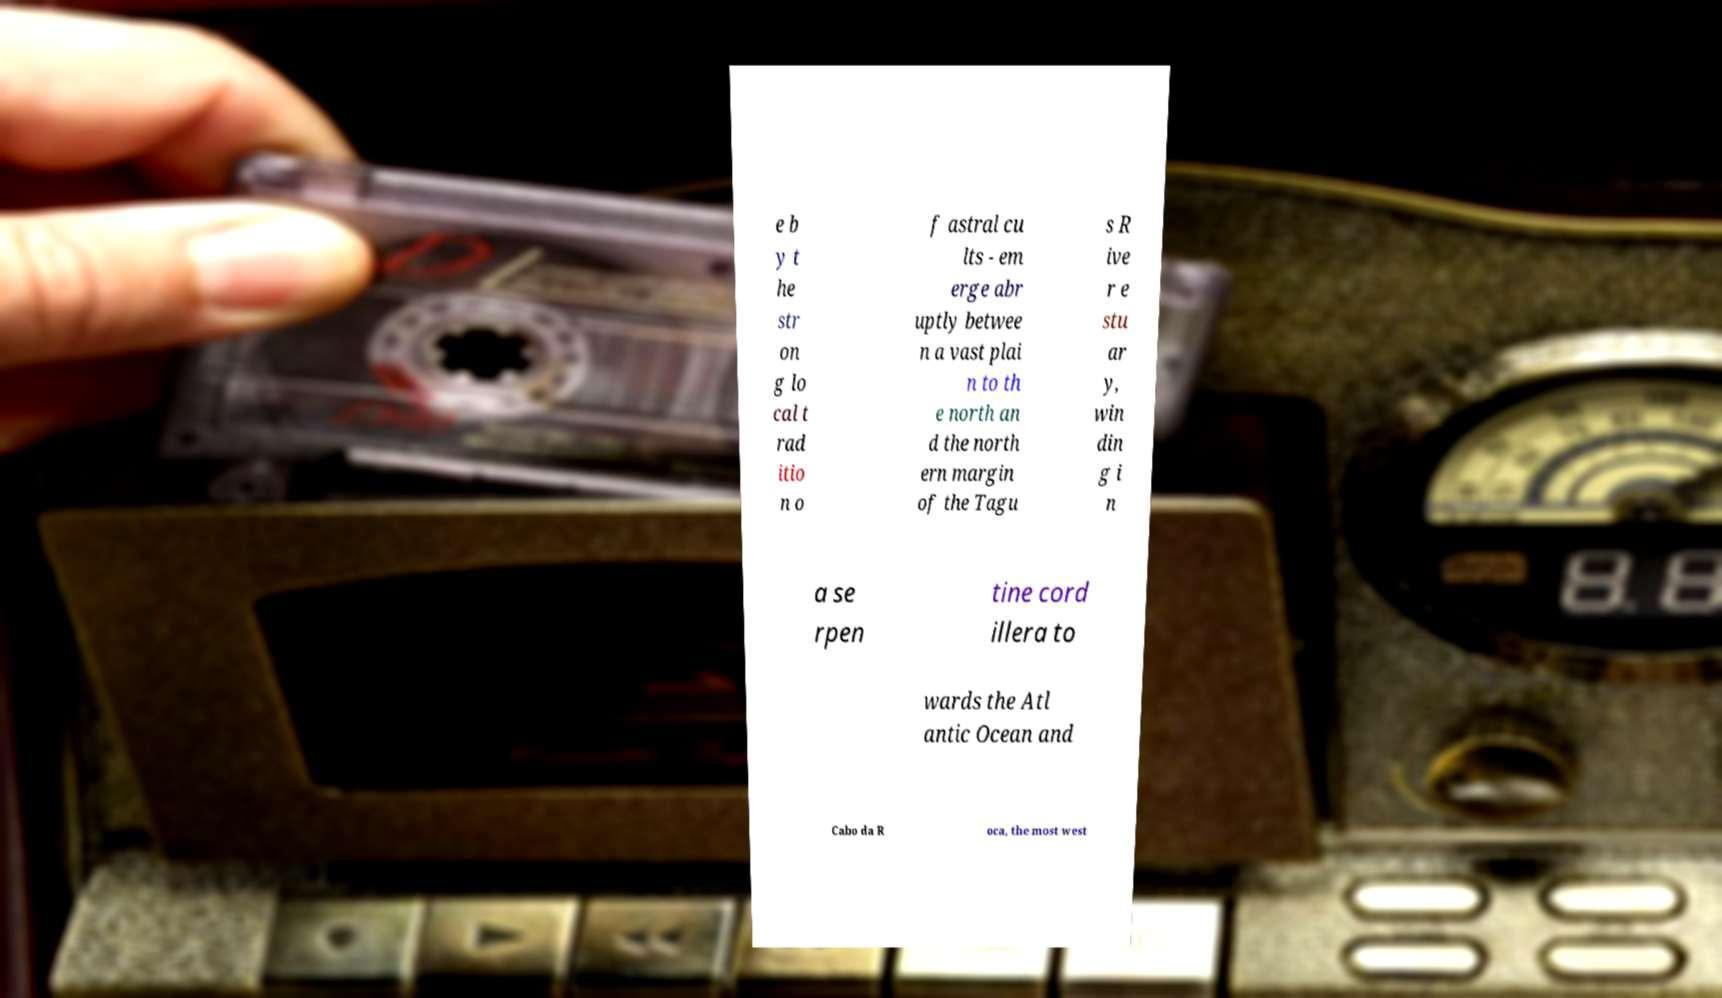I need the written content from this picture converted into text. Can you do that? e b y t he str on g lo cal t rad itio n o f astral cu lts - em erge abr uptly betwee n a vast plai n to th e north an d the north ern margin of the Tagu s R ive r e stu ar y, win din g i n a se rpen tine cord illera to wards the Atl antic Ocean and Cabo da R oca, the most west 